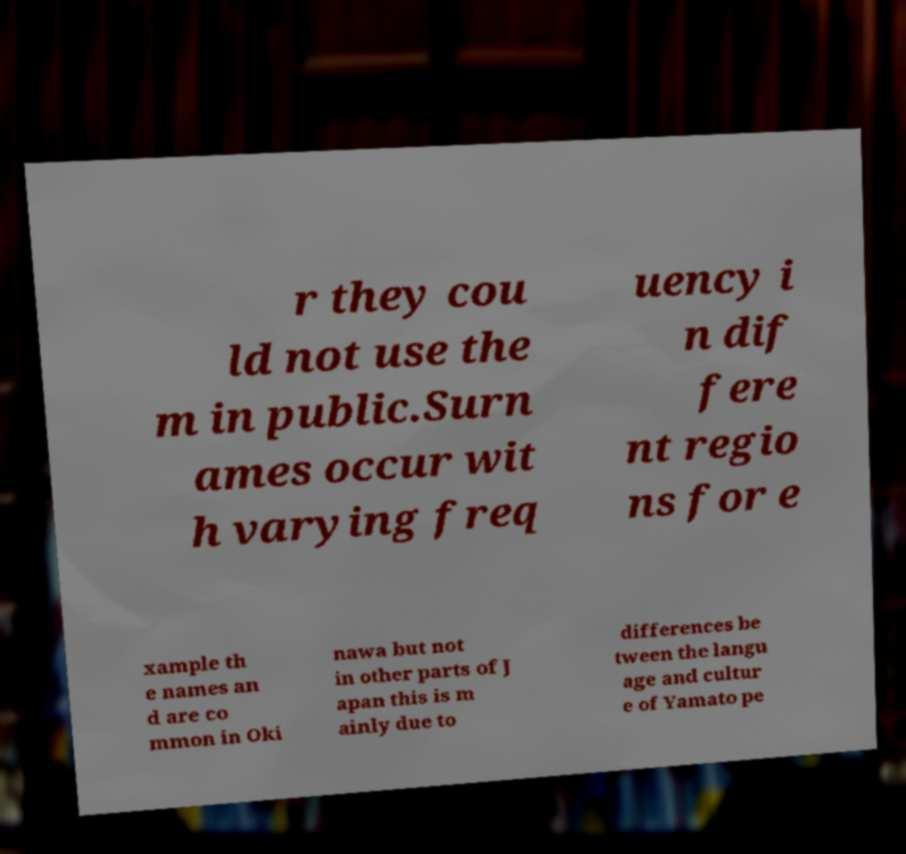Can you read and provide the text displayed in the image?This photo seems to have some interesting text. Can you extract and type it out for me? r they cou ld not use the m in public.Surn ames occur wit h varying freq uency i n dif fere nt regio ns for e xample th e names an d are co mmon in Oki nawa but not in other parts of J apan this is m ainly due to differences be tween the langu age and cultur e of Yamato pe 